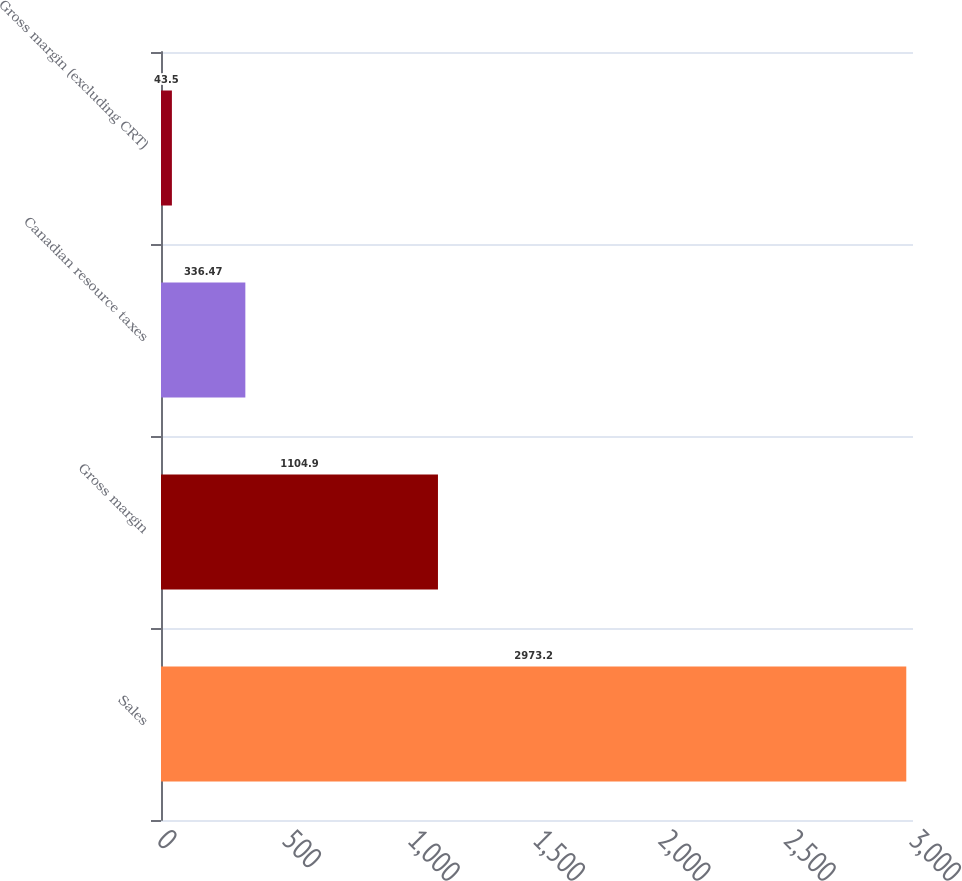<chart> <loc_0><loc_0><loc_500><loc_500><bar_chart><fcel>Sales<fcel>Gross margin<fcel>Canadian resource taxes<fcel>Gross margin (excluding CRT)<nl><fcel>2973.2<fcel>1104.9<fcel>336.47<fcel>43.5<nl></chart> 